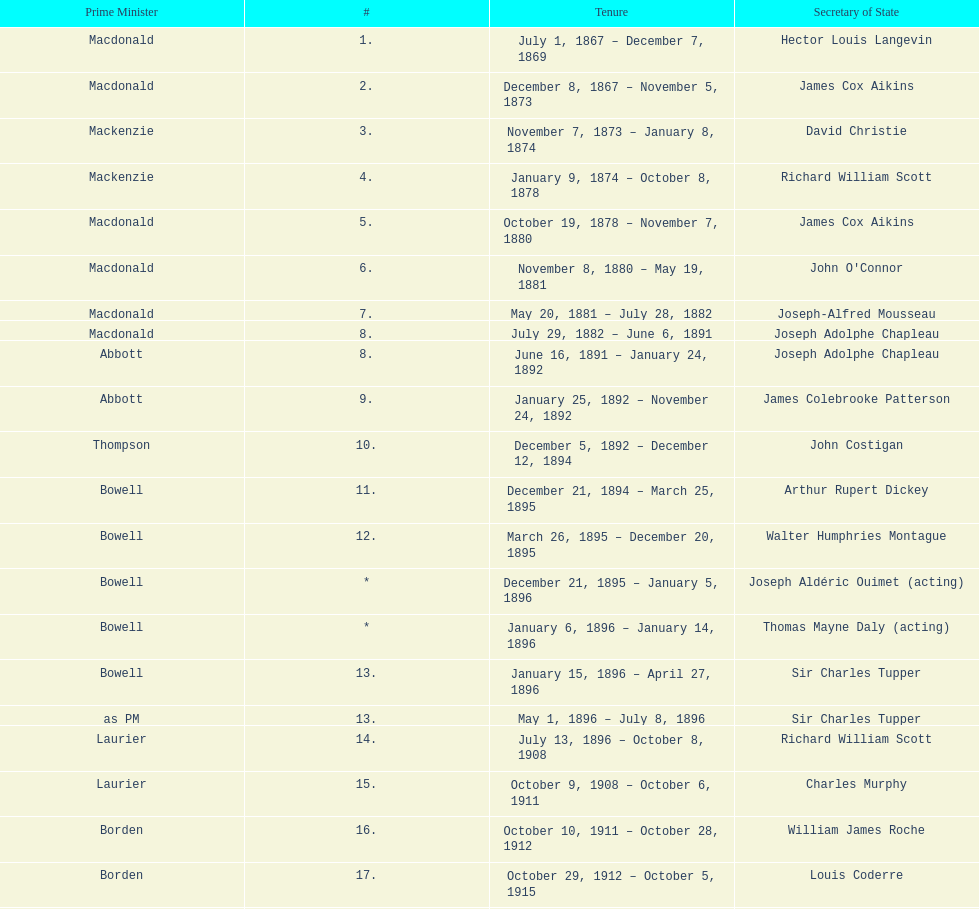Who was thompson's secretary of state? John Costigan. 